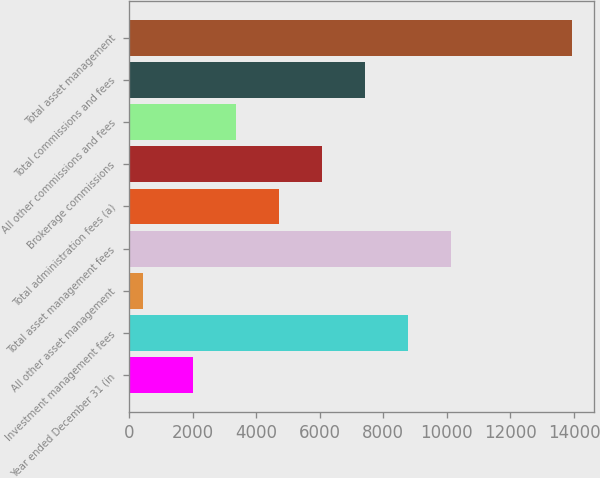Convert chart to OTSL. <chart><loc_0><loc_0><loc_500><loc_500><bar_chart><fcel>Year ended December 31 (in<fcel>Investment management fees<fcel>All other asset management<fcel>Total asset management fees<fcel>Total administration fees (a)<fcel>Brokerage commissions<fcel>All other commissions and fees<fcel>Total commissions and fees<fcel>Total asset management<nl><fcel>2008<fcel>8763.5<fcel>432<fcel>10114.6<fcel>4710.2<fcel>6061.3<fcel>3359.1<fcel>7412.4<fcel>13943<nl></chart> 